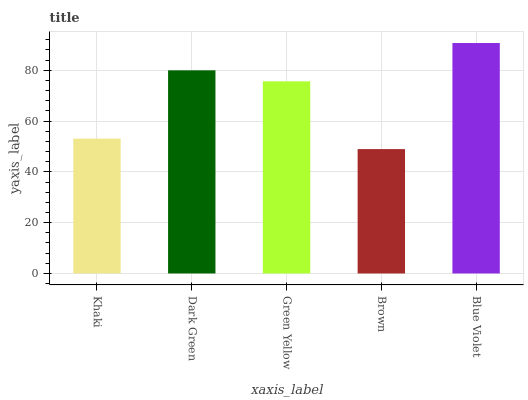Is Brown the minimum?
Answer yes or no. Yes. Is Blue Violet the maximum?
Answer yes or no. Yes. Is Dark Green the minimum?
Answer yes or no. No. Is Dark Green the maximum?
Answer yes or no. No. Is Dark Green greater than Khaki?
Answer yes or no. Yes. Is Khaki less than Dark Green?
Answer yes or no. Yes. Is Khaki greater than Dark Green?
Answer yes or no. No. Is Dark Green less than Khaki?
Answer yes or no. No. Is Green Yellow the high median?
Answer yes or no. Yes. Is Green Yellow the low median?
Answer yes or no. Yes. Is Khaki the high median?
Answer yes or no. No. Is Khaki the low median?
Answer yes or no. No. 